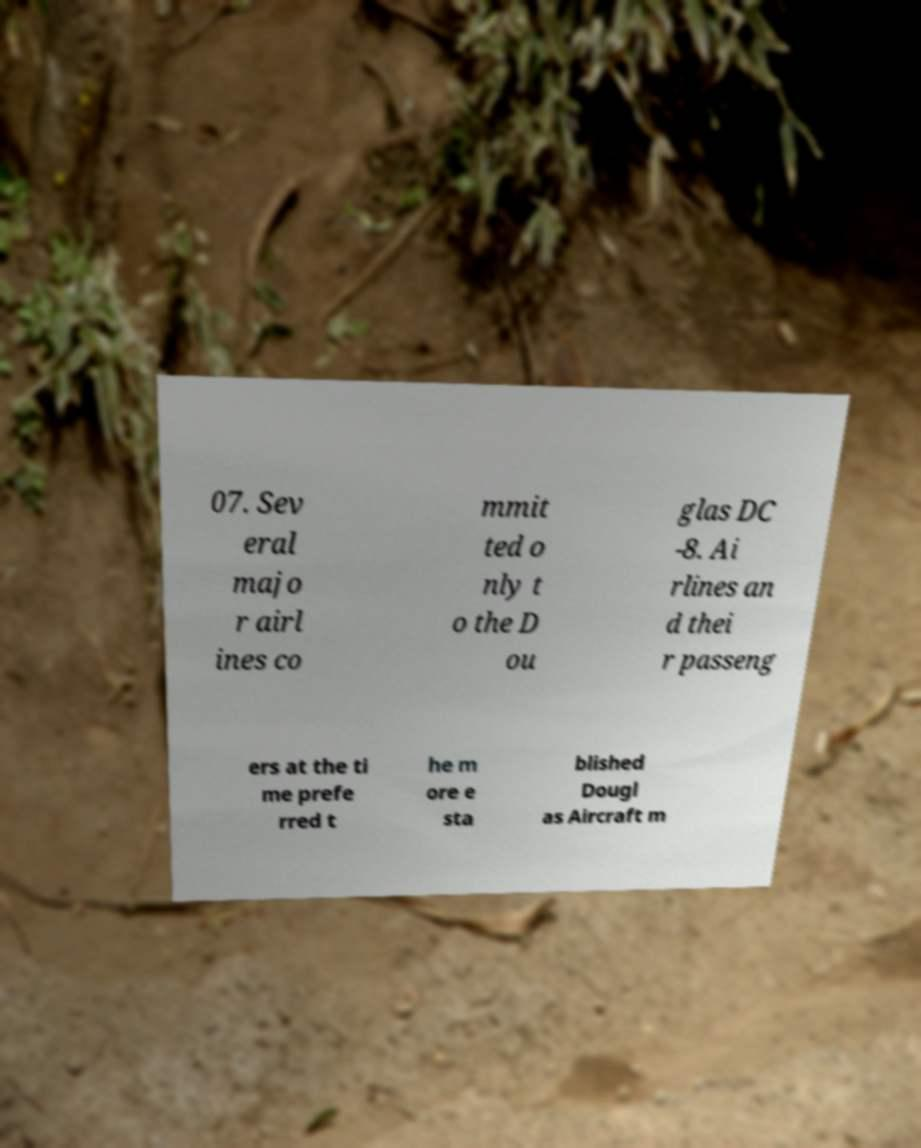Please identify and transcribe the text found in this image. 07. Sev eral majo r airl ines co mmit ted o nly t o the D ou glas DC -8. Ai rlines an d thei r passeng ers at the ti me prefe rred t he m ore e sta blished Dougl as Aircraft m 